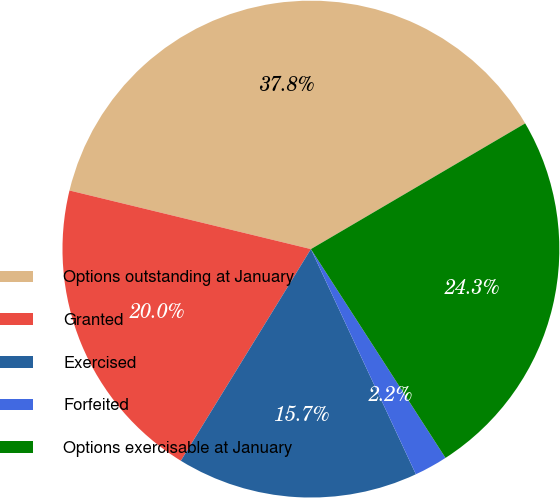<chart> <loc_0><loc_0><loc_500><loc_500><pie_chart><fcel>Options outstanding at January<fcel>Granted<fcel>Exercised<fcel>Forfeited<fcel>Options exercisable at January<nl><fcel>37.76%<fcel>20.02%<fcel>15.71%<fcel>2.17%<fcel>24.33%<nl></chart> 